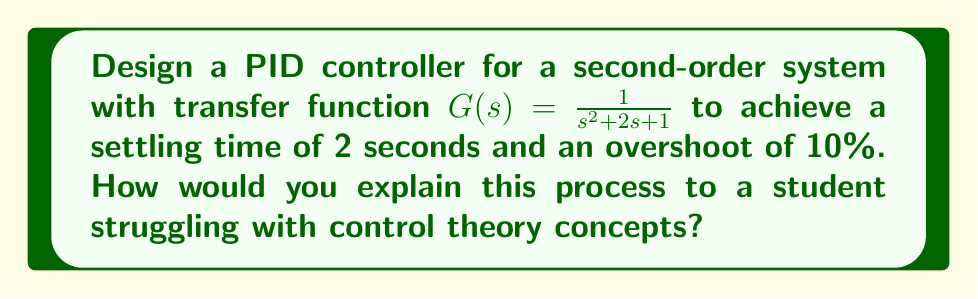Help me with this question. To design a PID controller for this system, we'll follow these steps:

1. Analyze the given system:
   The transfer function $G(s) = \frac{1}{s^2 + 2s + 1}$ represents a second-order system.

2. Determine the desired characteristics:
   - Settling time ($T_s$) = 2 seconds
   - Overshoot (OS) = 10%

3. Calculate the required damping ratio ($\zeta$) and natural frequency ($\omega_n$):
   - From the overshoot: $OS = e^{-\pi\zeta/\sqrt{1-\zeta^2}} \times 100\%$
     $0.10 = e^{-\pi\zeta/\sqrt{1-\zeta^2}}$
     Solving this, we get $\zeta \approx 0.591$

   - From the settling time: $T_s = \frac{4}{\zeta\omega_n}$
     $2 = \frac{4}{0.591\omega_n}$
     Solving this, we get $\omega_n \approx 3.38$ rad/s

4. Design the PID controller:
   The PID controller transfer function is:
   $C(s) = K_p + \frac{K_i}{s} + K_d s$

   We'll use the Ziegler-Nichols tuning method as a starting point:
   $K_p = 0.6K_u$
   $K_i = \frac{2K_p}{T_u}$
   $K_d = \frac{K_pT_u}{8}$

   Where $K_u$ is the ultimate gain and $T_u$ is the oscillation period.

5. Determine $K_u$ and $T_u$:
   For the given system, $K_u \approx 4$ and $T_u \approx 3.14$ seconds.

6. Calculate PID parameters:
   $K_p = 0.6 \times 4 = 2.4$
   $K_i = \frac{2 \times 2.4}{3.14} \approx 1.53$
   $K_d = \frac{2.4 \times 3.14}{8} \approx 0.94$

7. Fine-tune the parameters:
   Adjust these values slightly to meet the exact specifications.

To explain this process to a struggling student, use analogies and visual aids. For example, compare the PID controller to a car's cruise control system:
- P (Proportional): How quickly the car responds to speed changes
- I (Integral): How the car maintains the desired speed over time
- D (Derivative): How the car anticipates and smooths out changes

Use simulation tools to demonstrate the effects of changing each parameter on the system's response.
Answer: The PID controller parameters for the given second-order system to achieve a settling time of 2 seconds and an overshoot of 10% are approximately:

$K_p = 2.4$
$K_i = 1.53$
$K_d = 0.94$

These values may need fine-tuning to meet the exact specifications. 